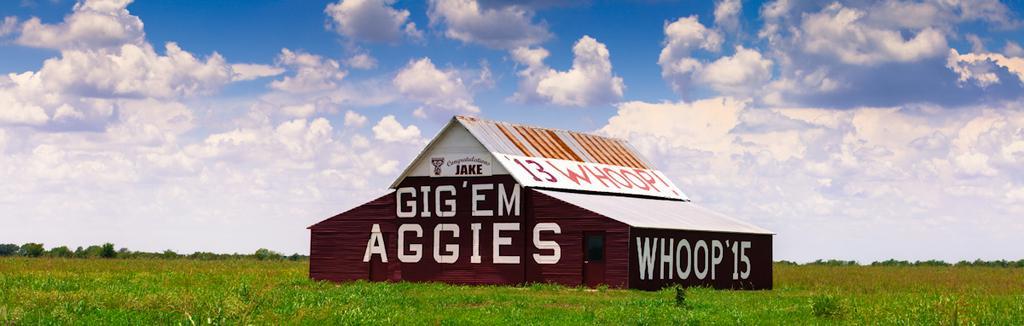Could you give a brief overview of what you see in this image? In this image in the center there is a house, and at the bottom there is grass. And in the background there are some plants, at the top there is sky and on the house there is text. 